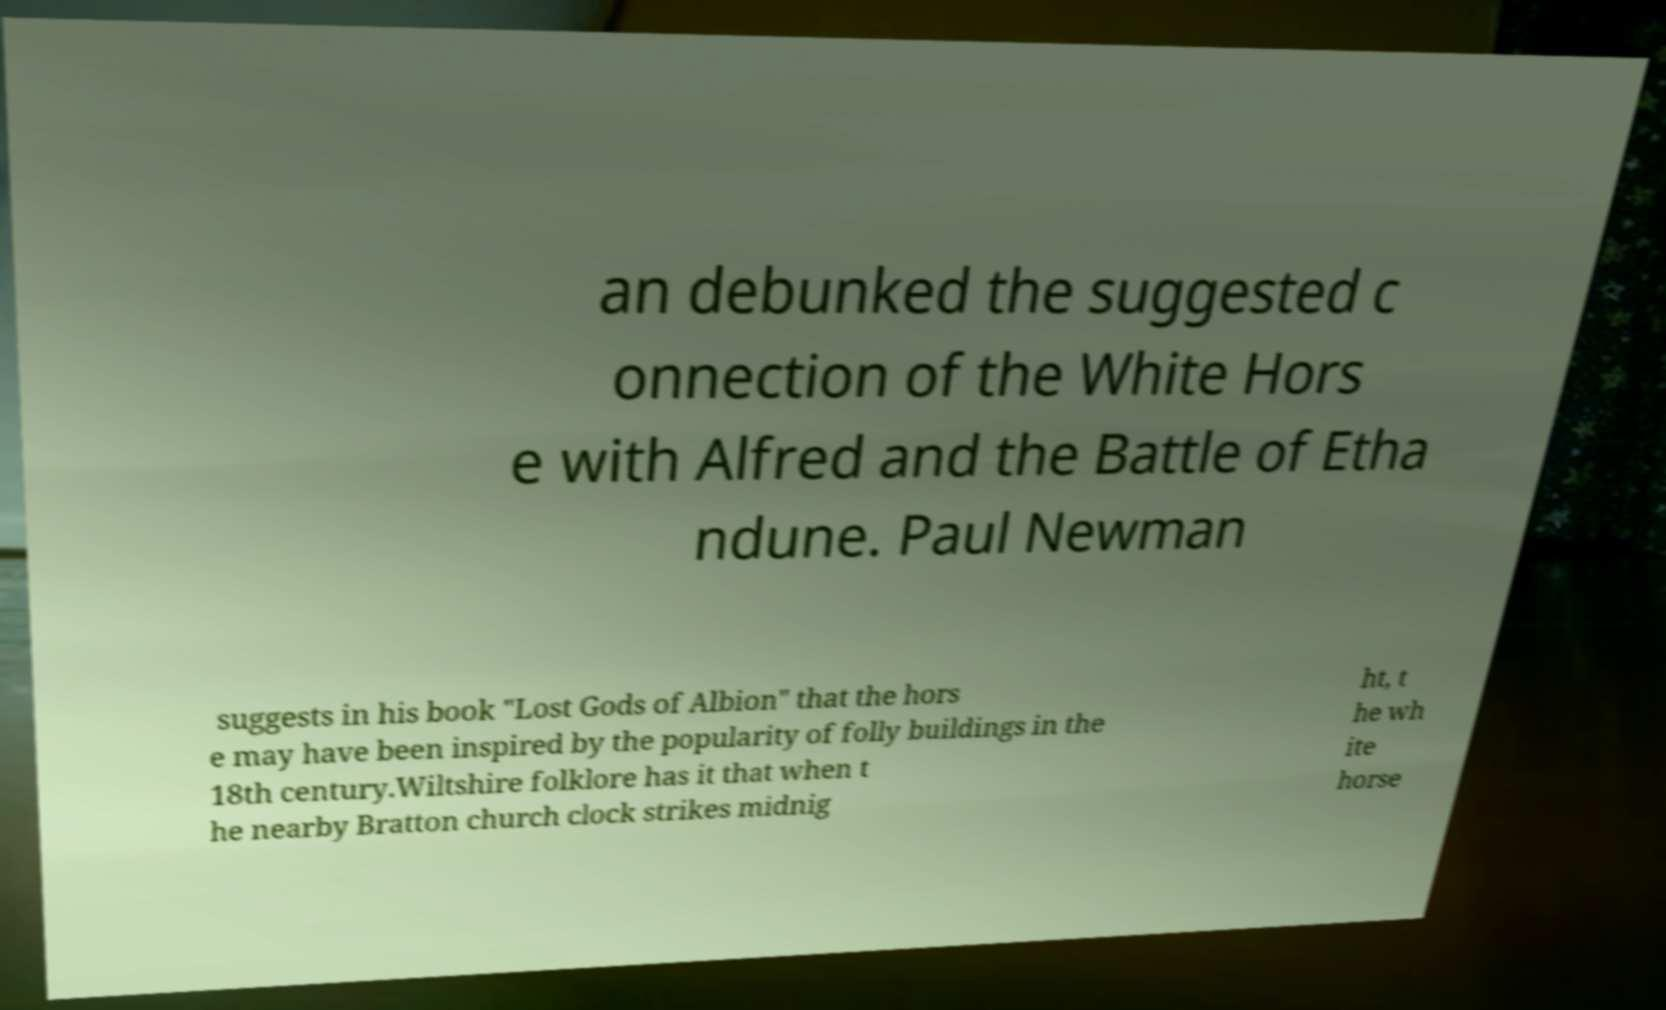Please identify and transcribe the text found in this image. an debunked the suggested c onnection of the White Hors e with Alfred and the Battle of Etha ndune. Paul Newman suggests in his book "Lost Gods of Albion" that the hors e may have been inspired by the popularity of folly buildings in the 18th century.Wiltshire folklore has it that when t he nearby Bratton church clock strikes midnig ht, t he wh ite horse 